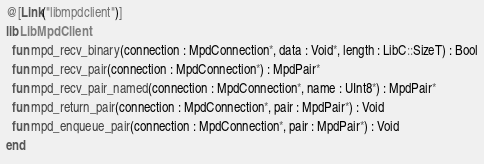Convert code to text. <code><loc_0><loc_0><loc_500><loc_500><_Crystal_>@[Link("libmpdclient")]
lib LibMpdClient
  fun mpd_recv_binary(connection : MpdConnection*, data : Void*, length : LibC::SizeT) : Bool
  fun mpd_recv_pair(connection : MpdConnection*) : MpdPair*
  fun mpd_recv_pair_named(connection : MpdConnection*, name : UInt8*) : MpdPair*
  fun mpd_return_pair(connection : MpdConnection*, pair : MpdPair*) : Void
  fun mpd_enqueue_pair(connection : MpdConnection*, pair : MpdPair*) : Void
end
</code> 